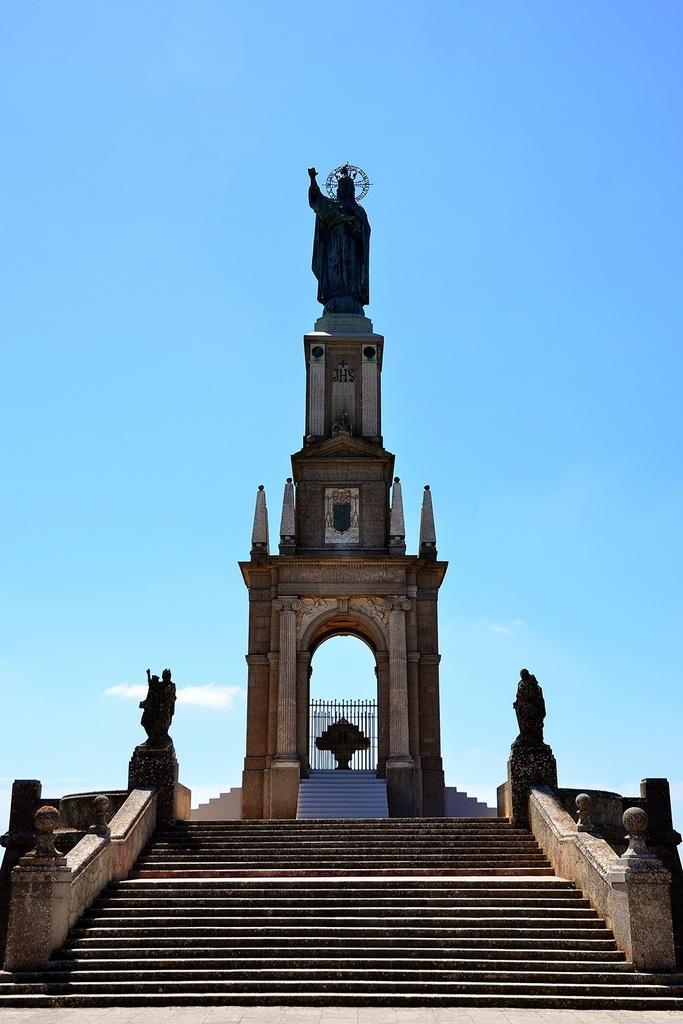How would you summarize this image in a sentence or two? In the center of the image there is a tower and we can see statue on the tower. At the bottom there are stairs. In the background there is sky. 